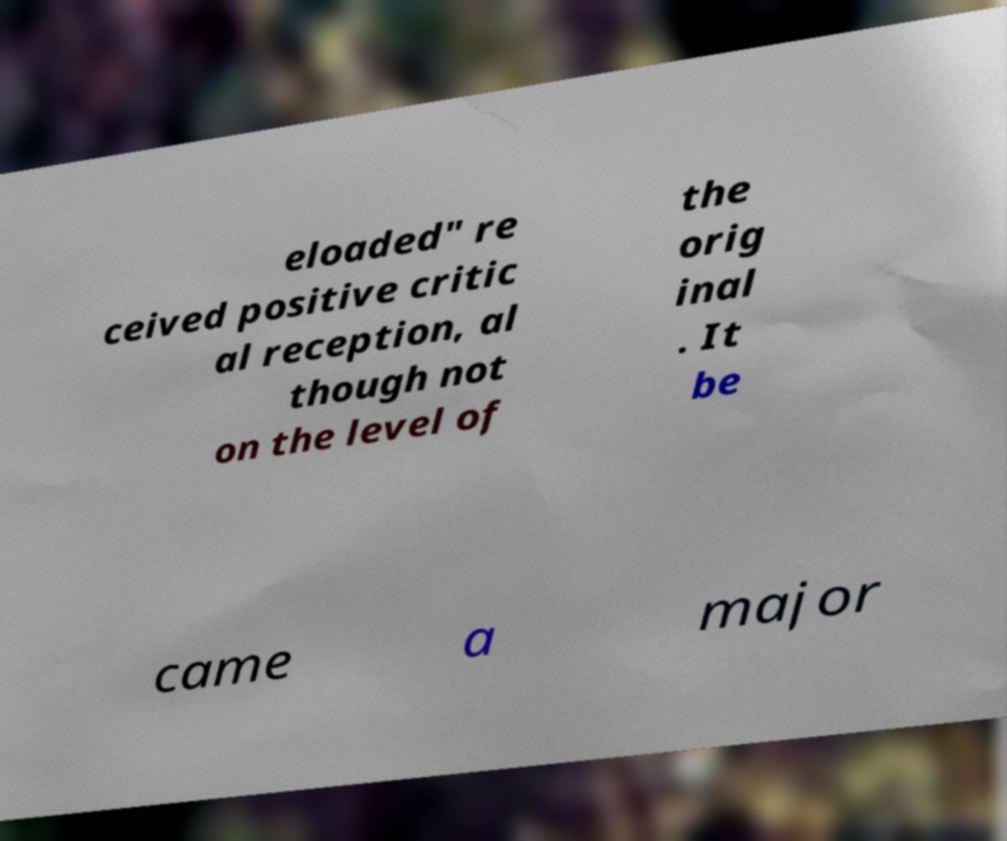Please identify and transcribe the text found in this image. eloaded" re ceived positive critic al reception, al though not on the level of the orig inal . It be came a major 